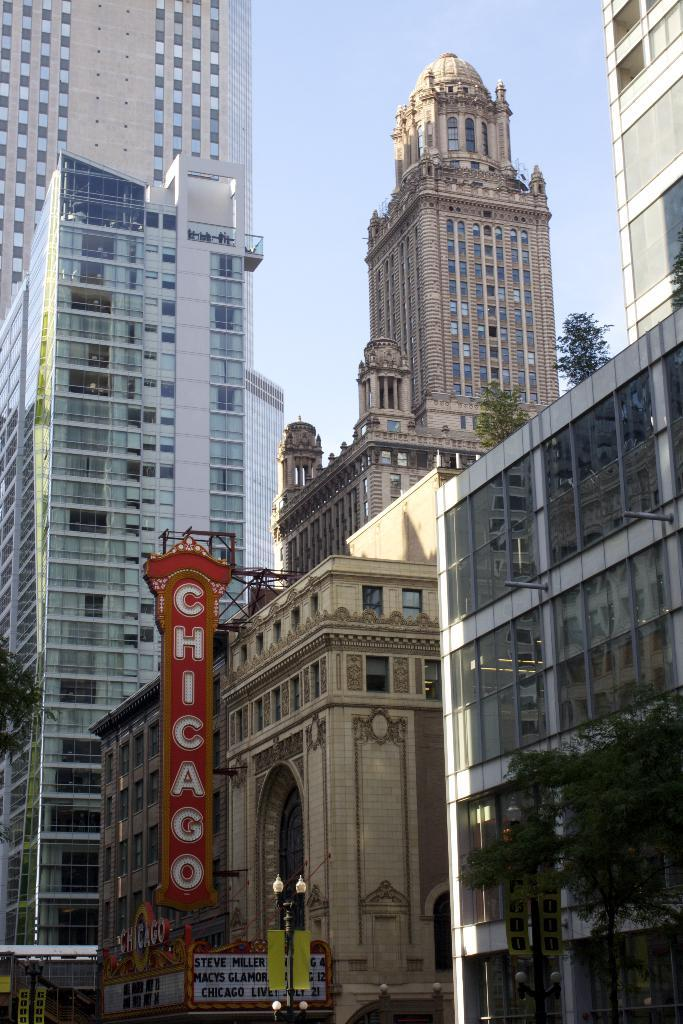What type of structures can be seen in the image? There are buildings in the image. What colors are the buildings? The buildings have white, blue, and cream colors. What other objects can be seen in the image? There are boards, a pole, lights attached to the pole, trees, and the sky visible in the background. How many frogs are sitting on the roof of the building in the image? There are no frogs present in the image. What type of muscle is being exercised by the people in the image? There are no people present in the image, so it is not possible to determine which muscles they might be exercising. 